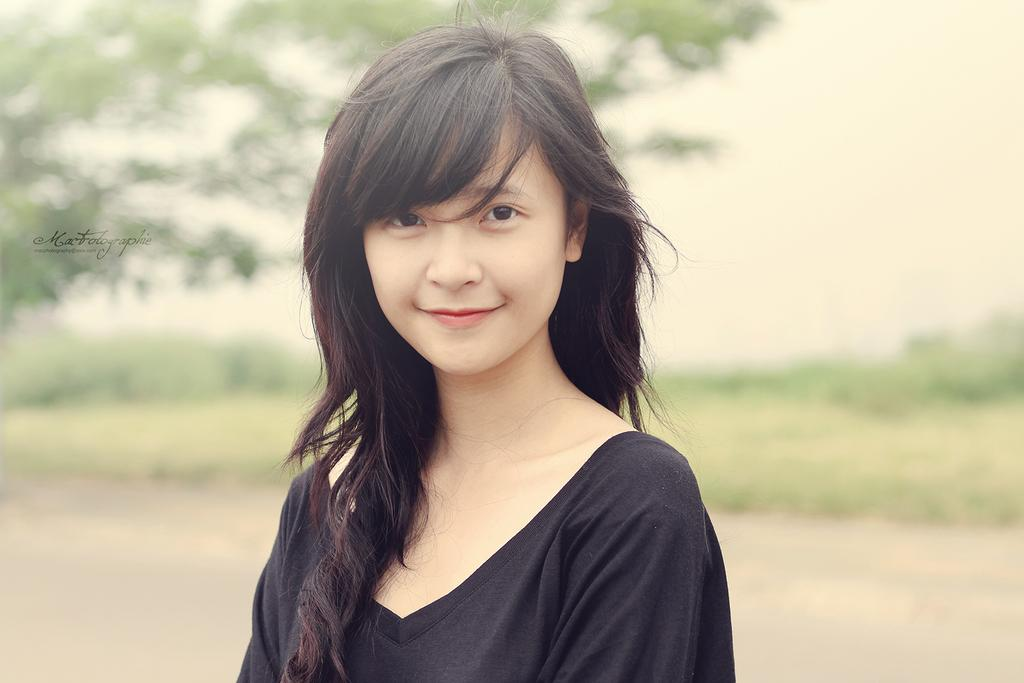Who is the main subject in the image? There is a girl in the image. What is the girl's expression in the image? The girl is smiling in the image. What can be seen in the background of the image? There is a road and trees in the background of the image. How would you describe the background of the image? The background appears blurry in the image. What color of paint is the girl using on her stocking in the image? There is no paint or stocking present in the image; the girl is simply smiling. 